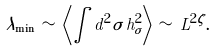<formula> <loc_0><loc_0><loc_500><loc_500>\lambda _ { \min } \, \sim \, \left \langle \int d ^ { 2 } { \sigma } \, h ^ { 2 } _ { \sigma } \right \rangle \, \sim \, L ^ { 2 \zeta } .</formula> 